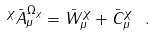<formula> <loc_0><loc_0><loc_500><loc_500>^ { \chi } \bar { A } ^ { \Omega _ { \chi } } _ { \mu } = \bar { W } ^ { \chi } _ { \mu } + \bar { C } ^ { \chi } _ { \mu } \ .</formula> 